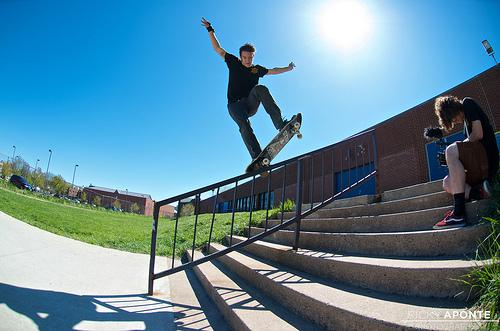Question: what is the boy doing?
Choices:
A. Skater.
B. Skiier.
C. Sledder.
D. Skateboarding.
Answer with the letter. Answer: D Question: what is the boy jumping over?
Choices:
A. Slope.
B. Hill.
C. Stairs.
D. Molehill.
Answer with the letter. Answer: C Question: who is with the boy?
Choices:
A. Girl.
B. Mother.
C. Friend.
D. Brother.
Answer with the letter. Answer: A Question: who is sitting on the stairs?
Choices:
A. Girl.
B. Boy.
C. Family.
D. Children.
Answer with the letter. Answer: A 